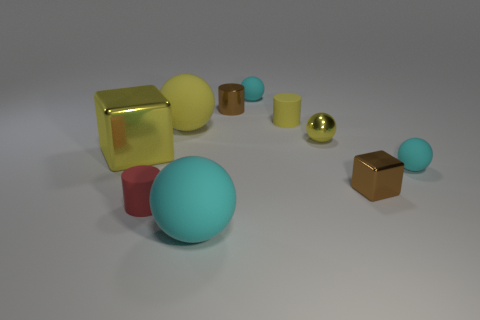Subtract all brown cylinders. How many cyan spheres are left? 3 Subtract all big yellow balls. How many balls are left? 4 Subtract all purple balls. Subtract all brown blocks. How many balls are left? 5 Subtract all cubes. How many objects are left? 8 Add 4 tiny brown things. How many tiny brown things exist? 6 Subtract 0 green balls. How many objects are left? 10 Subtract all large matte balls. Subtract all tiny cyan rubber spheres. How many objects are left? 6 Add 9 tiny metal spheres. How many tiny metal spheres are left? 10 